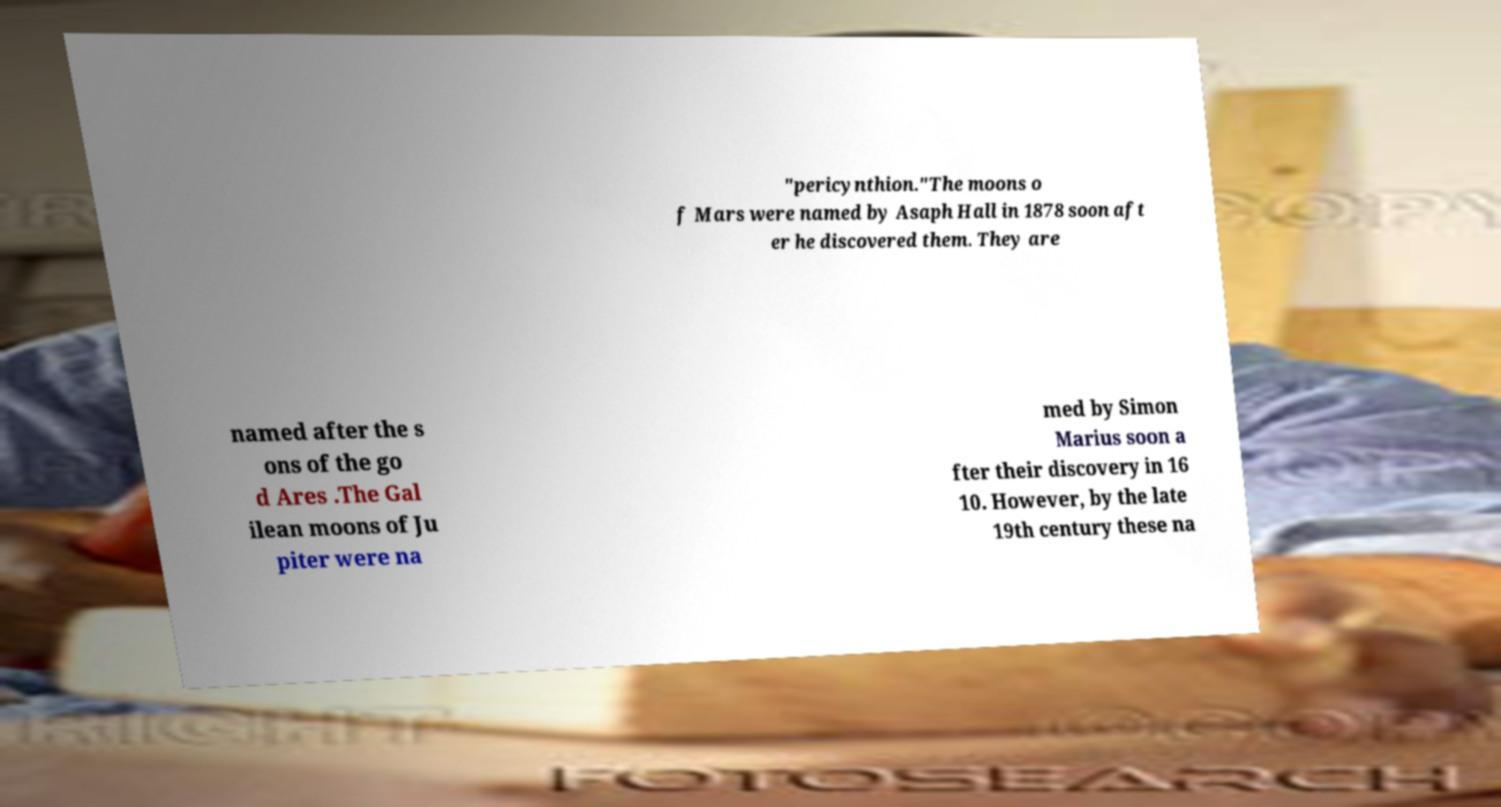Please identify and transcribe the text found in this image. "pericynthion."The moons o f Mars were named by Asaph Hall in 1878 soon aft er he discovered them. They are named after the s ons of the go d Ares .The Gal ilean moons of Ju piter were na med by Simon Marius soon a fter their discovery in 16 10. However, by the late 19th century these na 